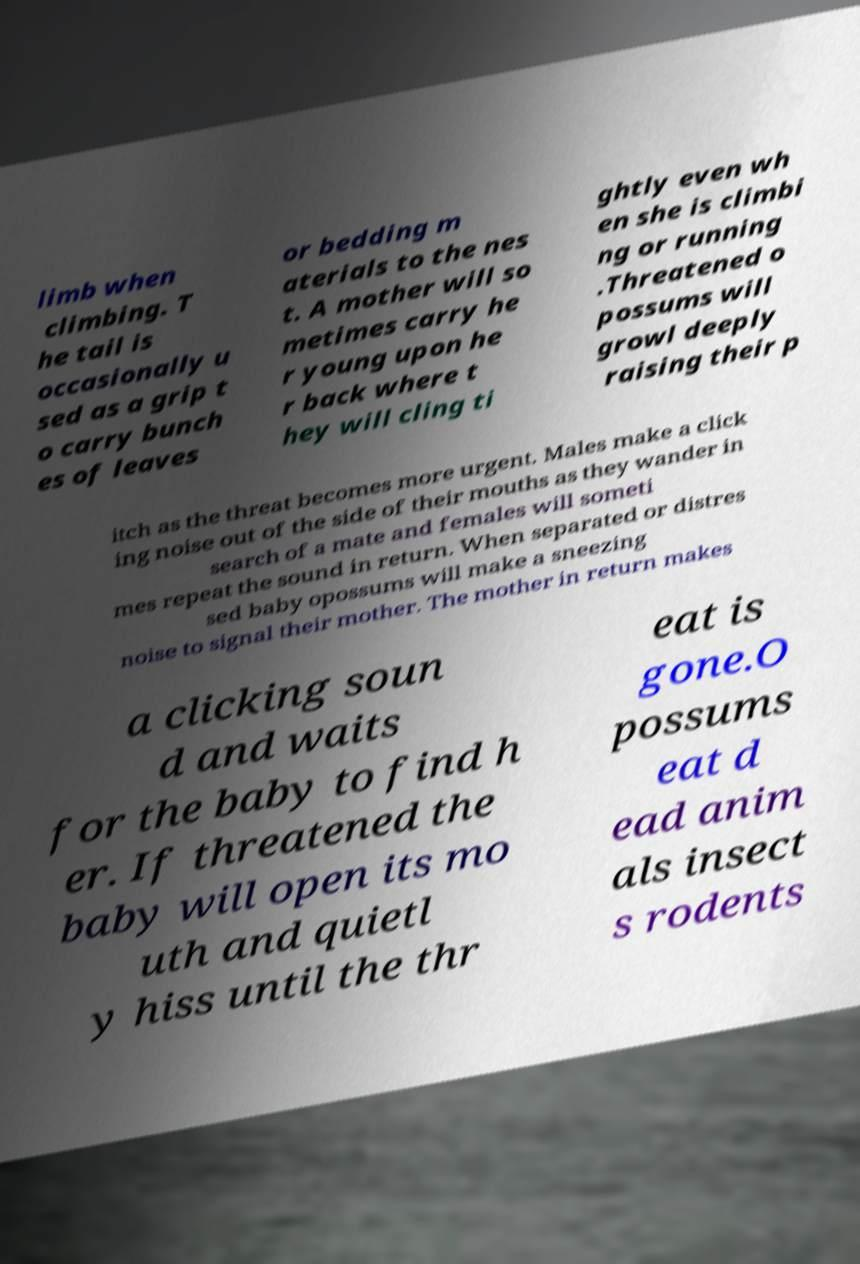Can you accurately transcribe the text from the provided image for me? limb when climbing. T he tail is occasionally u sed as a grip t o carry bunch es of leaves or bedding m aterials to the nes t. A mother will so metimes carry he r young upon he r back where t hey will cling ti ghtly even wh en she is climbi ng or running .Threatened o possums will growl deeply raising their p itch as the threat becomes more urgent. Males make a click ing noise out of the side of their mouths as they wander in search of a mate and females will someti mes repeat the sound in return. When separated or distres sed baby opossums will make a sneezing noise to signal their mother. The mother in return makes a clicking soun d and waits for the baby to find h er. If threatened the baby will open its mo uth and quietl y hiss until the thr eat is gone.O possums eat d ead anim als insect s rodents 